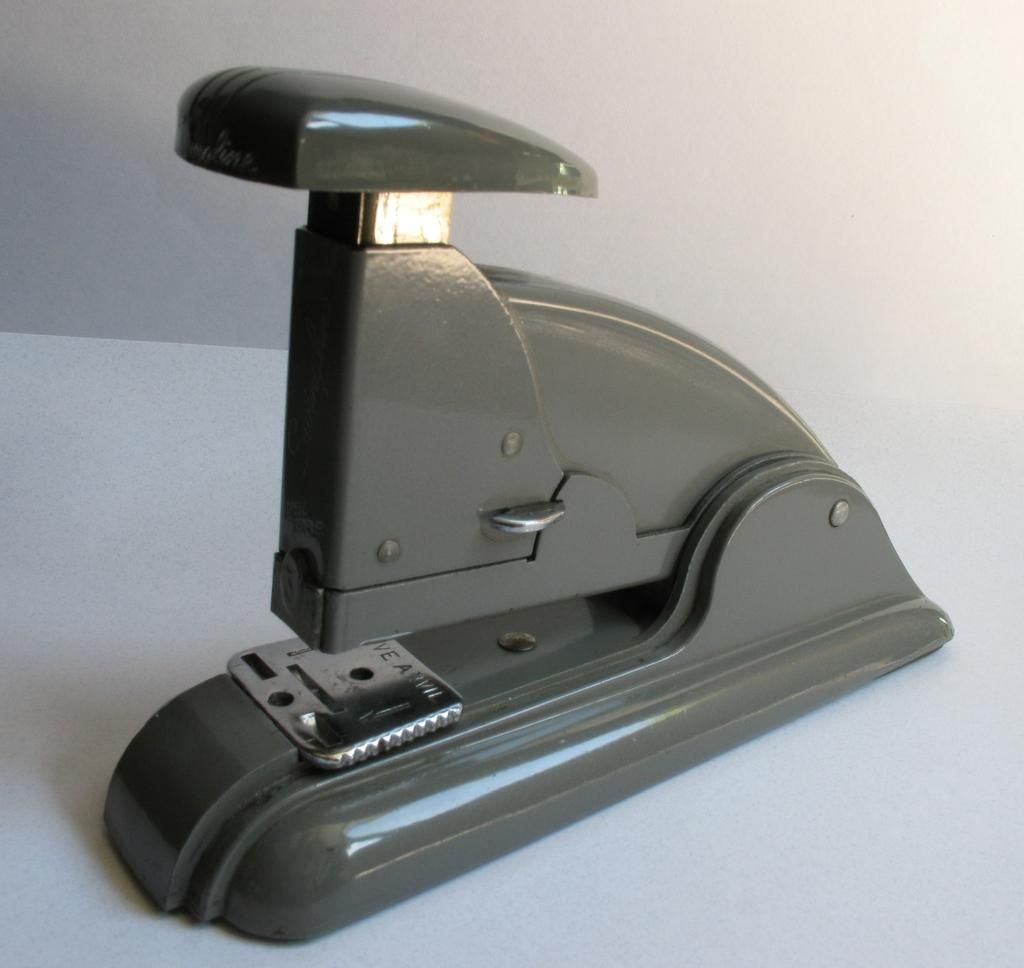What type of structure can be seen in the image? There is a wall in the image. What piece of furniture is present in the image? There is a table in the image. What object is placed on the table? There is a paper hole punch on the table. Can you see any flies in the image? There are no flies present in the image. Is this image taken in a bedroom? The provided facts do not mention the location or type of room, so it cannot be determined if it is a bedroom. 